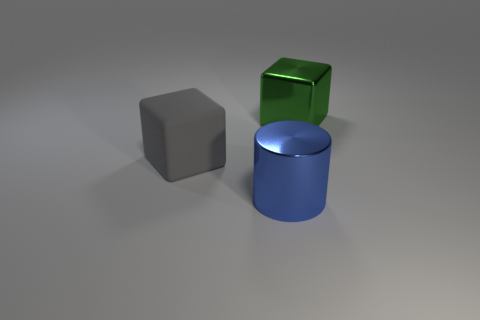There is a matte thing that is the same size as the metallic block; what is its shape? The matte object shares its size with the metallic block and has a cubic shape. It displays six faces of equal square dimensions, each face meeting its adjacent faces at right angles, characteristic of a cube. 